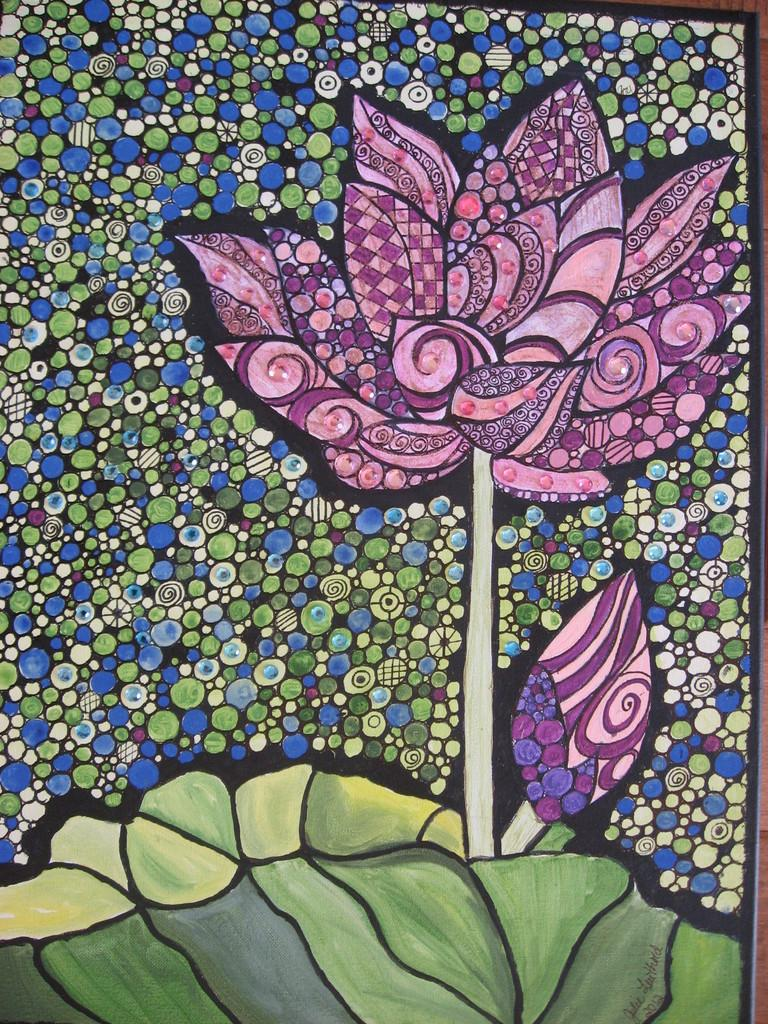What is the main subject of the image? There is a flower painted in the image. What color is the flower? The flower is in pink color. What else can be seen in the image besides the flower? There are leaves in the image. What color are the leaves? The leaves are in green color. What colors are present in the background of the image? The background of the image includes blue, cream, and green colors. Can you hear the sound of the horn in the image? There is no horn present in the image, so it is not possible to hear any sound. 